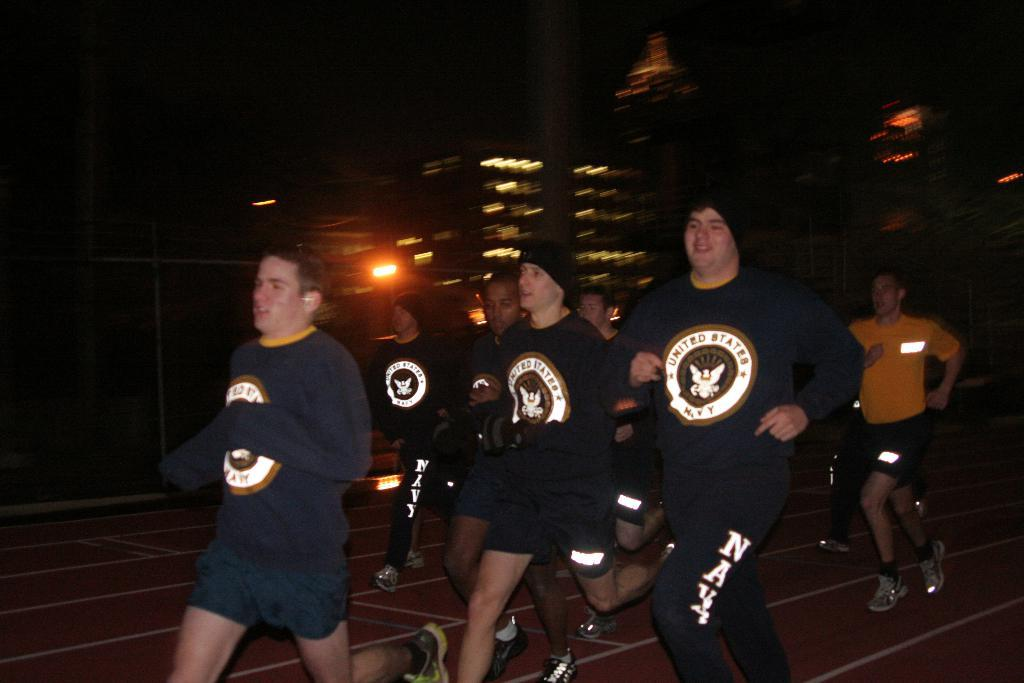What is happening with the group of people in the image? The people are running in the image. What can be seen in the background of the image? There are buildings and lights visible in the background of the image. What type of sail can be seen on the books in the image? There are no books or sails present in the image; it features a group of people running with buildings and lights in the background. 